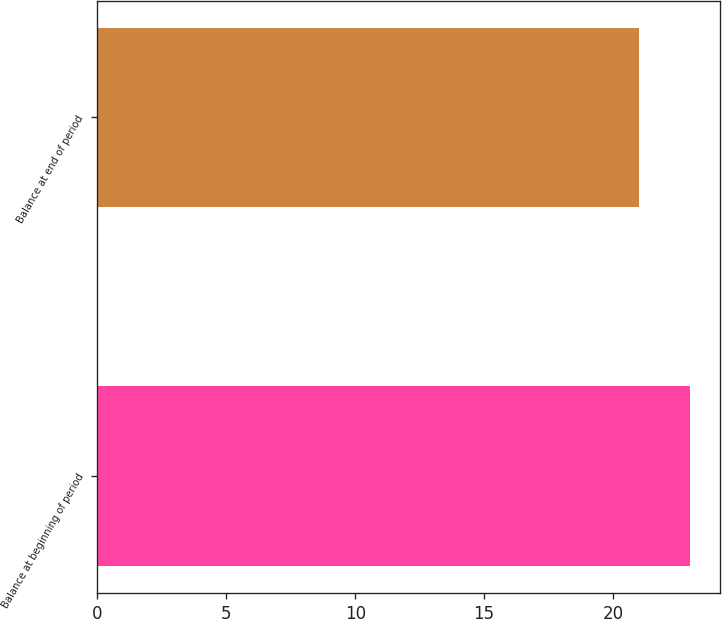Convert chart to OTSL. <chart><loc_0><loc_0><loc_500><loc_500><bar_chart><fcel>Balance at beginning of period<fcel>Balance at end of period<nl><fcel>23<fcel>21<nl></chart> 